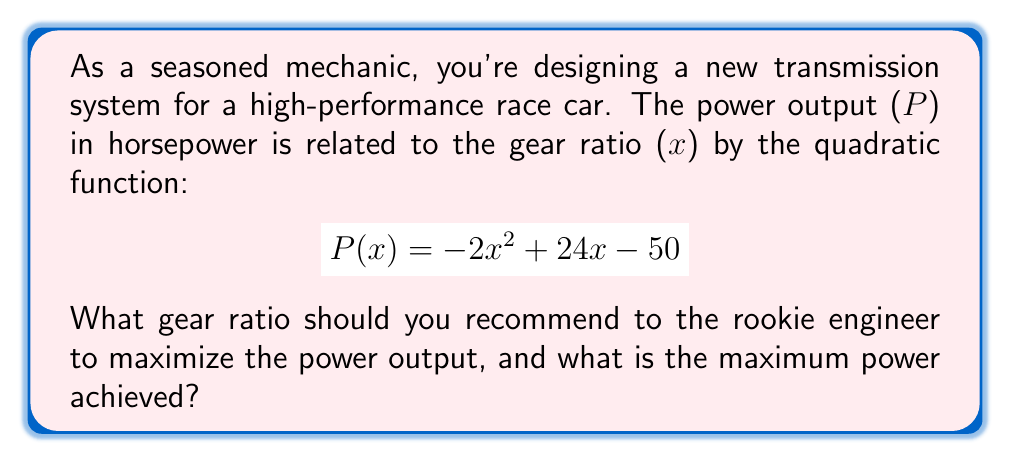Teach me how to tackle this problem. To solve this problem, we'll follow these steps:

1) The power output is given by a quadratic function. To find the maximum, we need to find the vertex of the parabola.

2) For a quadratic function in the form $f(x) = ax^2 + bx + c$, the x-coordinate of the vertex is given by $x = -\frac{b}{2a}$.

3) In our function $P(x) = -2x^2 + 24x - 50$, we have:
   $a = -2$
   $b = 24$
   $c = -50$

4) Substituting into the vertex formula:

   $$x = -\frac{24}{2(-2)} = -\frac{24}{-4} = 6$$

5) This means the optimal gear ratio is 6.

6) To find the maximum power, we substitute x = 6 into the original function:

   $$P(6) = -2(6)^2 + 24(6) - 50$$
   $$= -2(36) + 144 - 50$$
   $$= -72 + 144 - 50$$
   $$= 22$$

Therefore, the maximum power output is 22 horsepower.
Answer: Optimal gear ratio: 6, Maximum power: 22 horsepower 